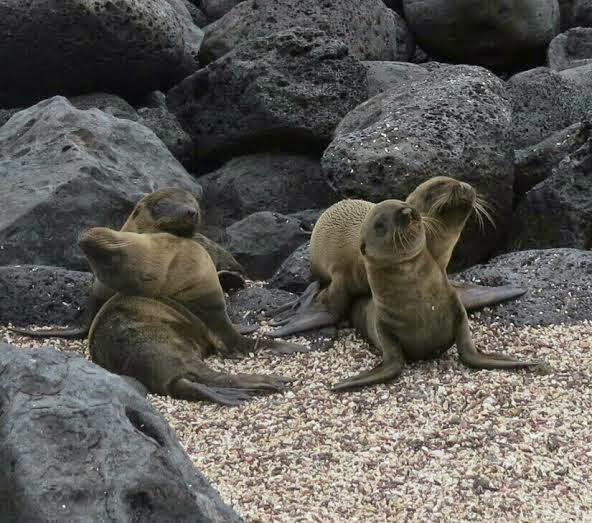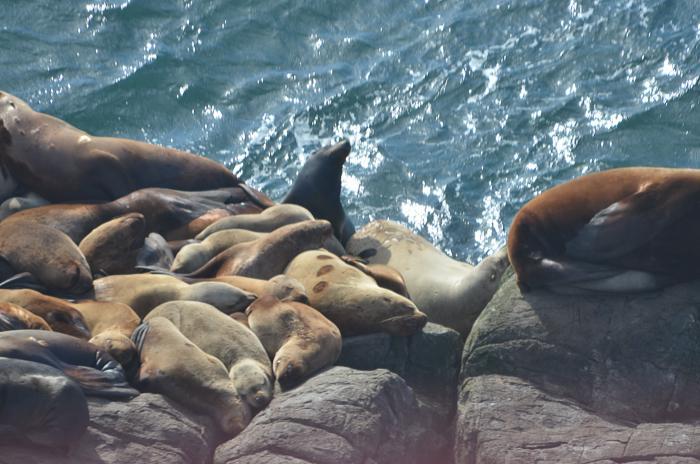The first image is the image on the left, the second image is the image on the right. Considering the images on both sides, is "No image contains more than seven seals, and at least one image shows seals on a rock above water." valid? Answer yes or no. No. The first image is the image on the left, the second image is the image on the right. Considering the images on both sides, is "There are no more than three seals sunning in one of the images." valid? Answer yes or no. No. 